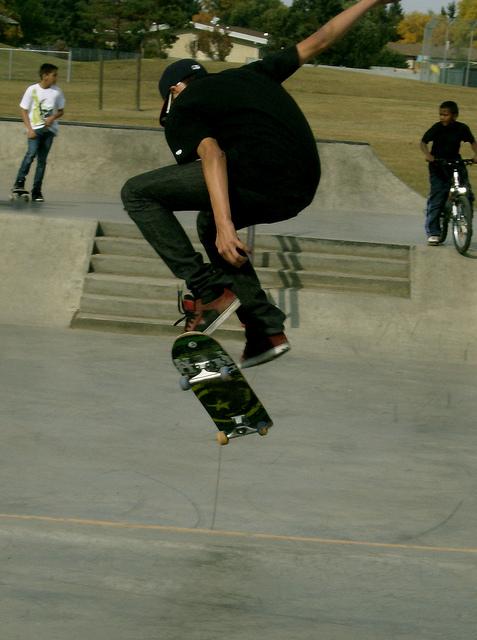Is the man holding a frisbee?
Answer briefly. No. Is there graffiti on the ground?
Be succinct. No. Is anything not on the ground?
Write a very short answer. Yes. Is this a circus trick?
Quick response, please. No. How many steps are there?
Give a very brief answer. 6. What is on his right knee?
Write a very short answer. Jeans. Is the image in black and white?
Concise answer only. No. What activity are these people participating in?
Write a very short answer. Skateboarding. How far off the ground is the skateboard?
Short answer required. 2 feet. What type of art has been painted on the skate ramp?
Give a very brief answer. None. Where is the man located on the tennis court?
Be succinct. Center. Are they about to fall?
Keep it brief. No. What is the man in black doing?
Short answer required. Skateboarding. 